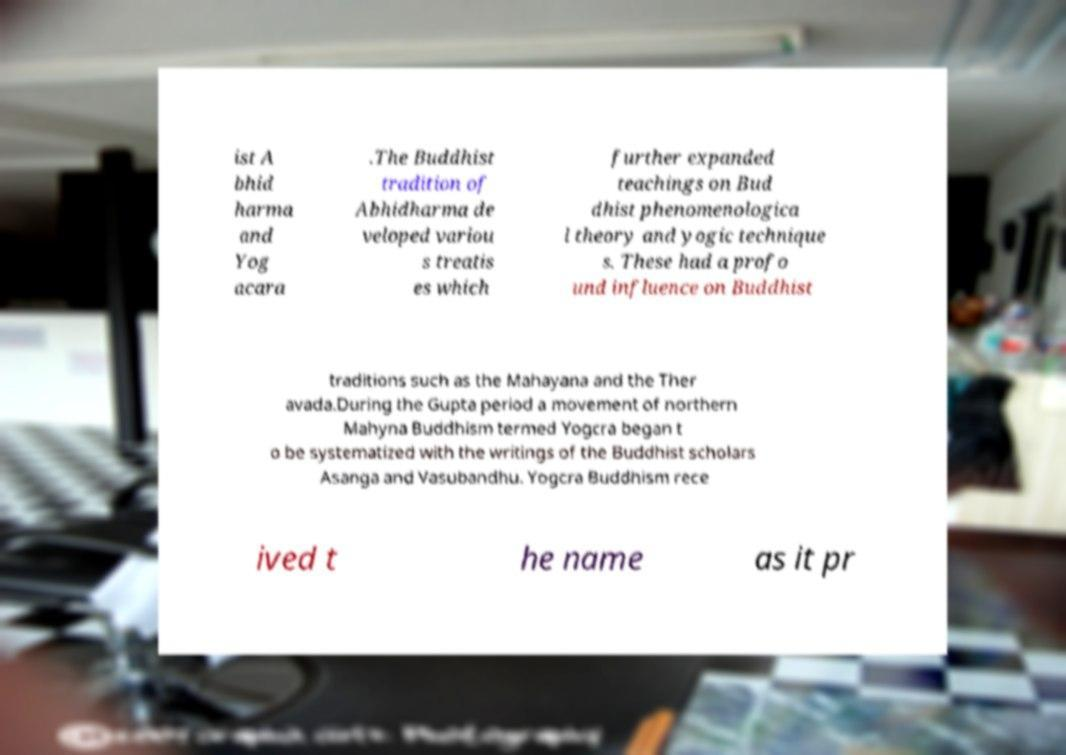Please read and relay the text visible in this image. What does it say? ist A bhid harma and Yog acara .The Buddhist tradition of Abhidharma de veloped variou s treatis es which further expanded teachings on Bud dhist phenomenologica l theory and yogic technique s. These had a profo und influence on Buddhist traditions such as the Mahayana and the Ther avada.During the Gupta period a movement of northern Mahyna Buddhism termed Yogcra began t o be systematized with the writings of the Buddhist scholars Asanga and Vasubandhu. Yogcra Buddhism rece ived t he name as it pr 